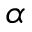Convert formula to latex. <formula><loc_0><loc_0><loc_500><loc_500>\alpha</formula> 